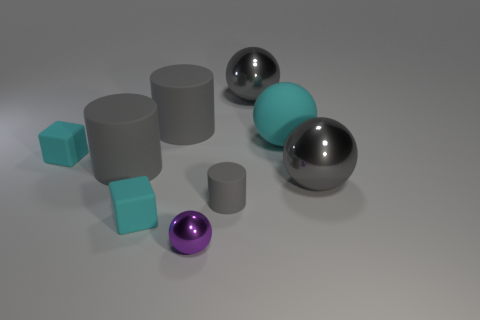Subtract all tiny cylinders. How many cylinders are left? 2 Add 1 gray rubber objects. How many objects exist? 10 Subtract all cyan spheres. How many spheres are left? 3 Subtract 0 green cubes. How many objects are left? 9 Subtract all cylinders. How many objects are left? 6 Subtract 2 cylinders. How many cylinders are left? 1 Subtract all gray cubes. Subtract all cyan cylinders. How many cubes are left? 2 Subtract all cyan cubes. How many yellow spheres are left? 0 Subtract all gray rubber things. Subtract all gray spheres. How many objects are left? 4 Add 5 cyan things. How many cyan things are left? 8 